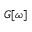Convert formula to latex. <formula><loc_0><loc_0><loc_500><loc_500>G [ \omega ]</formula> 